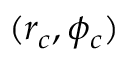<formula> <loc_0><loc_0><loc_500><loc_500>( r _ { c } , \phi _ { c } )</formula> 